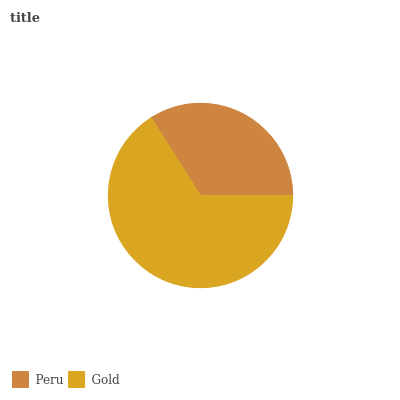Is Peru the minimum?
Answer yes or no. Yes. Is Gold the maximum?
Answer yes or no. Yes. Is Gold the minimum?
Answer yes or no. No. Is Gold greater than Peru?
Answer yes or no. Yes. Is Peru less than Gold?
Answer yes or no. Yes. Is Peru greater than Gold?
Answer yes or no. No. Is Gold less than Peru?
Answer yes or no. No. Is Gold the high median?
Answer yes or no. Yes. Is Peru the low median?
Answer yes or no. Yes. Is Peru the high median?
Answer yes or no. No. Is Gold the low median?
Answer yes or no. No. 